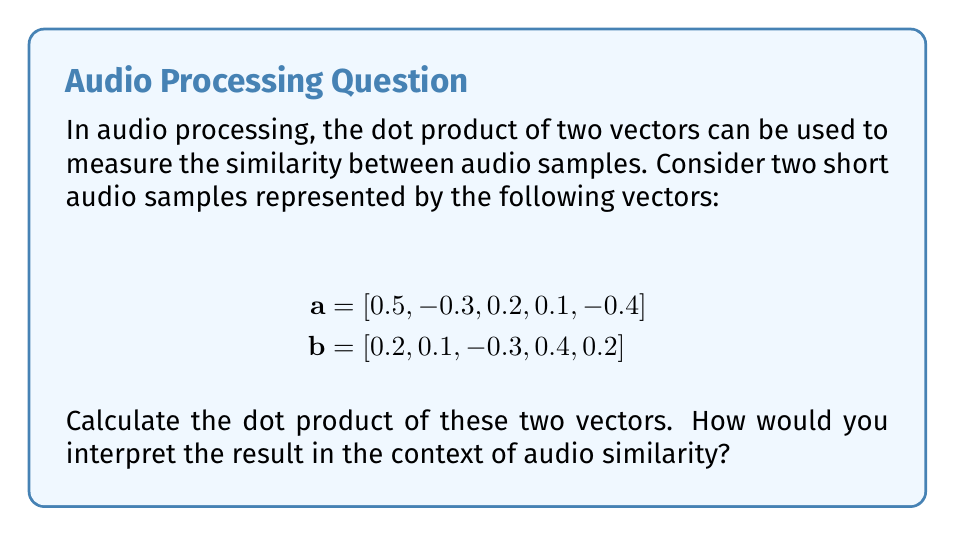Can you solve this math problem? To calculate the dot product of two vectors, we multiply corresponding elements and sum the results. Let's break it down step-by-step:

1) The dot product formula for two vectors $\mathbf{a}$ and $\mathbf{b}$ is:

   $$\mathbf{a} \cdot \mathbf{b} = \sum_{i=1}^n a_i b_i$$

2) For our vectors:
   $$\mathbf{a} \cdot \mathbf{b} = (0.5 \times 0.2) + (-0.3 \times 0.1) + (0.2 \times -0.3) + (0.1 \times 0.4) + (-0.4 \times 0.2)$$

3) Let's calculate each term:
   - $0.5 \times 0.2 = 0.1$
   - $-0.3 \times 0.1 = -0.03$
   - $0.2 \times -0.3 = -0.06$
   - $0.1 \times 0.4 = 0.04$
   - $-0.4 \times 0.2 = -0.08$

4) Sum all terms:
   $$0.1 + (-0.03) + (-0.06) + 0.04 + (-0.08) = -0.03$$

5) Interpretation: The dot product is -0.03, which is close to zero. In audio processing, a dot product close to zero suggests that the two audio samples are not very similar or are nearly orthogonal. If the samples were more similar, we would expect a larger positive value. If they were inverse of each other, we would see a large negative value.
Answer: $-0.03$ 